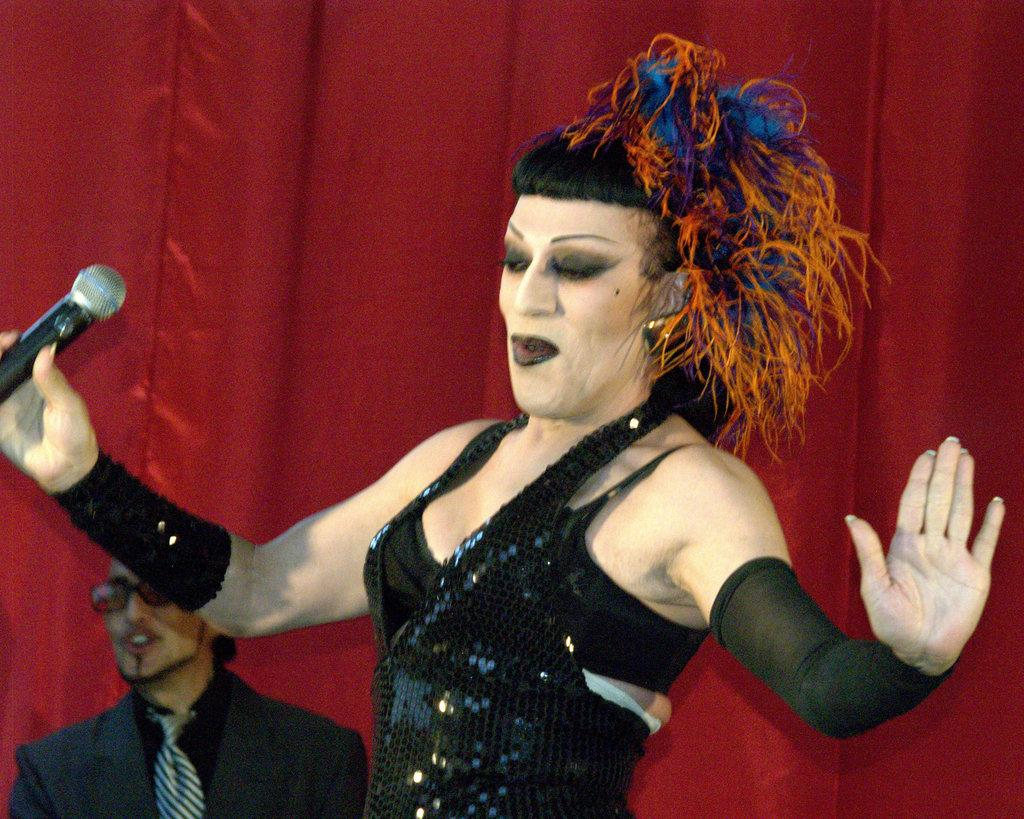What is the woman in the image holding? The woman is holding a mic in her hand. What is the woman's facial expression in the image? The woman is smiling in the image. Can you describe the person wearing a blazer, tie, and spectacles in the image? There is a person wearing a blazer, tie, and spectacles in the image. What color is the curtain in the background of the image? The curtain in the background of the image is red. What does the woman hate about the wrist in the image? There is no mention of a wrist or any negative emotions in the image. 